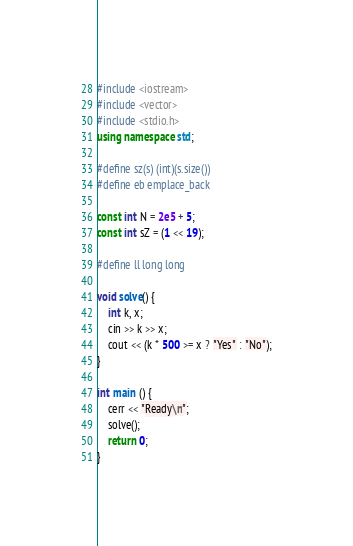Convert code to text. <code><loc_0><loc_0><loc_500><loc_500><_C++_>#include <iostream>
#include <vector>
#include <stdio.h>
using namespace std;

#define sz(s) (int)(s.size())
#define eb emplace_back

const int N = 2e5 + 5;
const int sZ = (1 << 19);

#define ll long long

void solve() {
	int k, x;
	cin >> k >> x;
	cout << (k * 500 >= x ? "Yes" : "No");
}

int main () {
	cerr << "Ready\n";
	solve();
	return 0;
}
</code> 